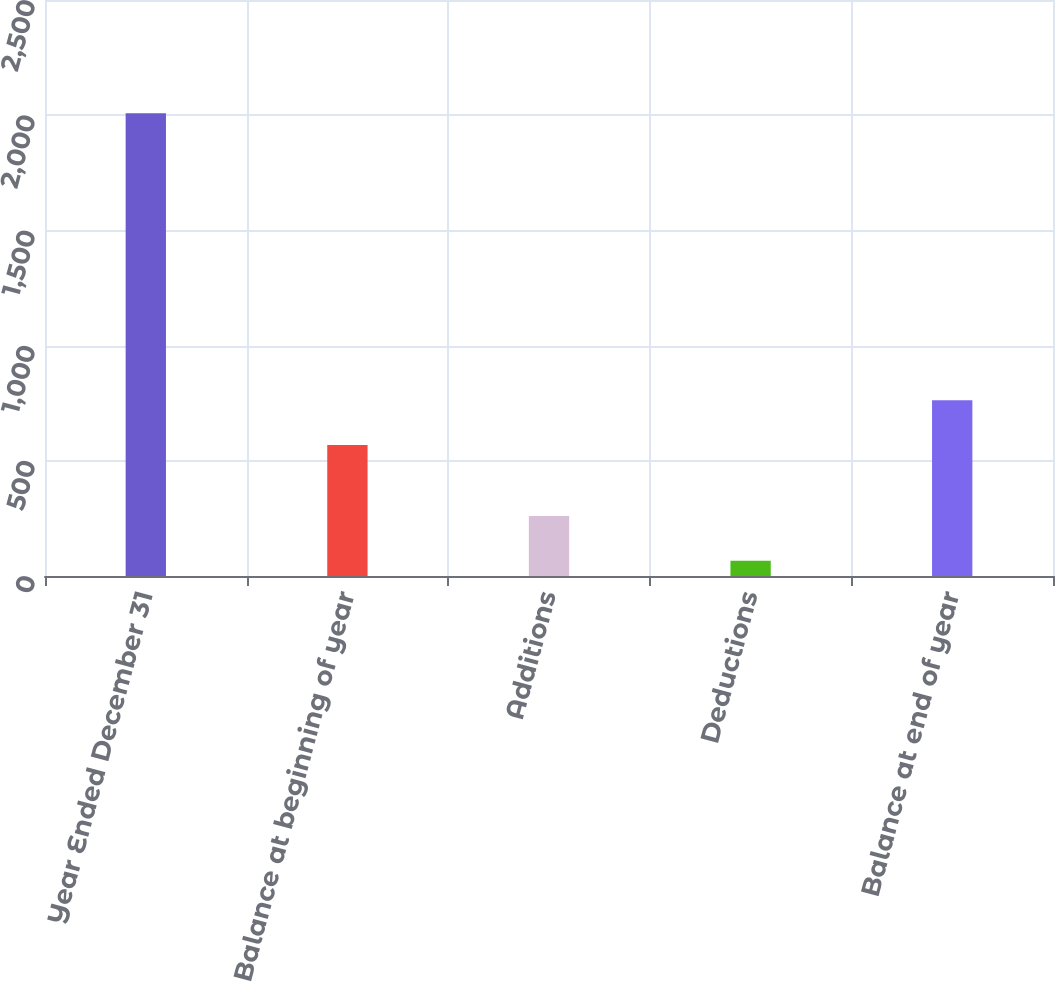<chart> <loc_0><loc_0><loc_500><loc_500><bar_chart><fcel>Year Ended December 31<fcel>Balance at beginning of year<fcel>Additions<fcel>Deductions<fcel>Balance at end of year<nl><fcel>2009<fcel>569<fcel>260.3<fcel>66<fcel>763.3<nl></chart> 